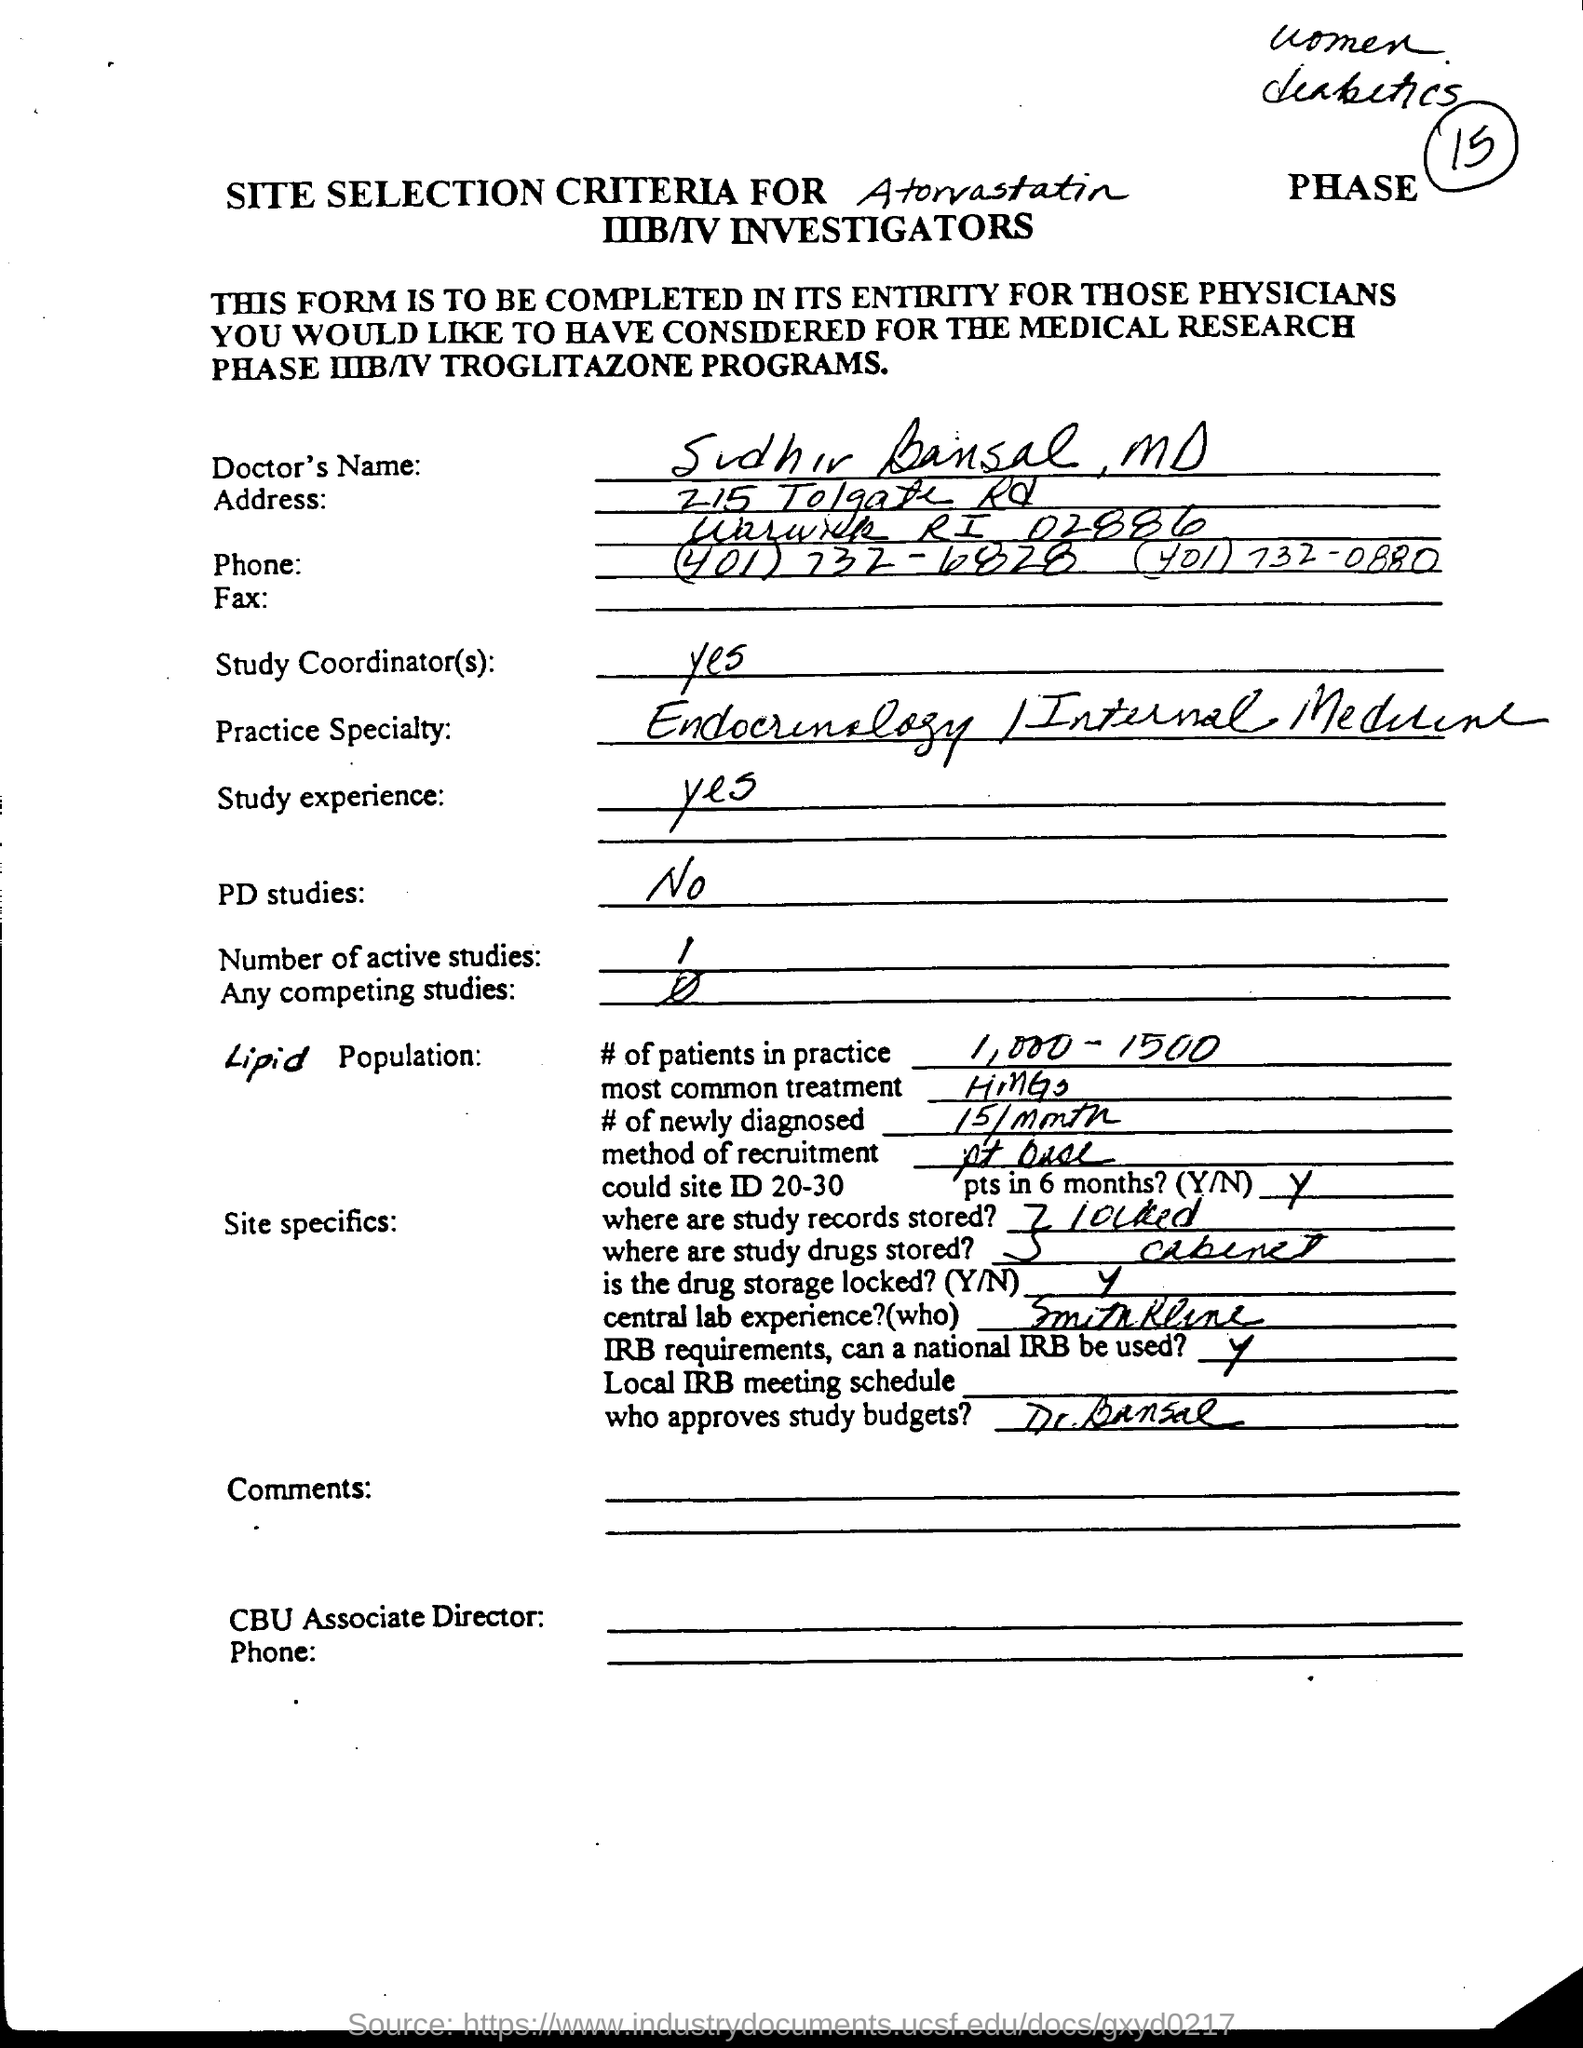What is the doctor's name ?
Provide a succinct answer. Sudhir Bansal, MD. 